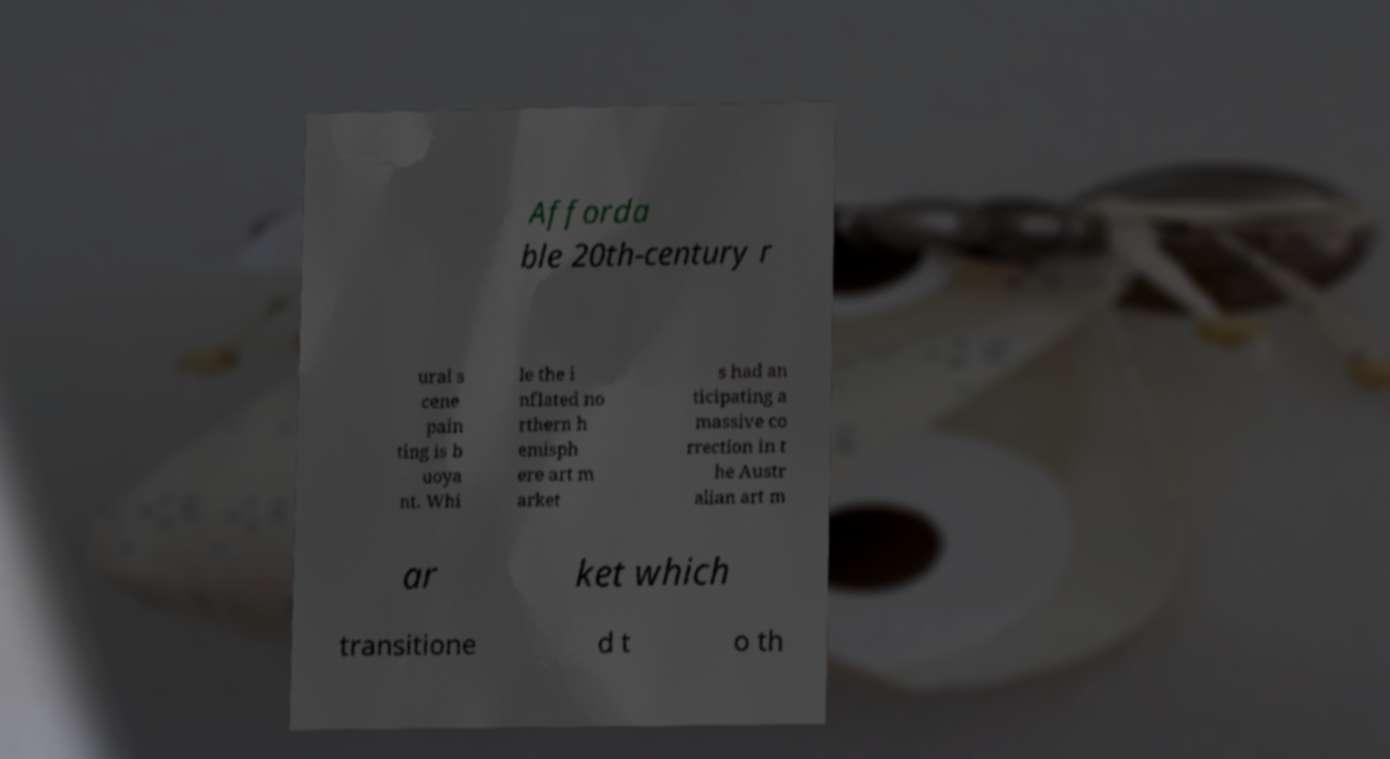Please read and relay the text visible in this image. What does it say? Afforda ble 20th-century r ural s cene pain ting is b uoya nt. Whi le the i nflated no rthern h emisph ere art m arket s had an ticipating a massive co rrection in t he Austr alian art m ar ket which transitione d t o th 